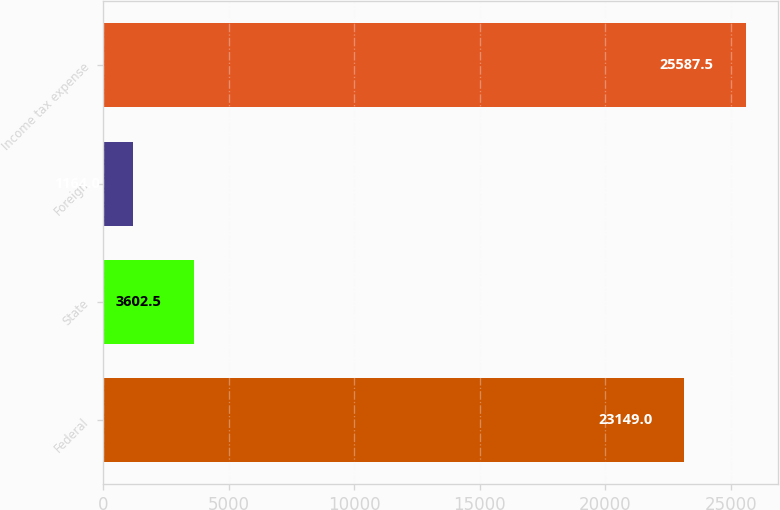Convert chart. <chart><loc_0><loc_0><loc_500><loc_500><bar_chart><fcel>Federal<fcel>State<fcel>Foreign<fcel>Income tax expense<nl><fcel>23149<fcel>3602.5<fcel>1164<fcel>25587.5<nl></chart> 